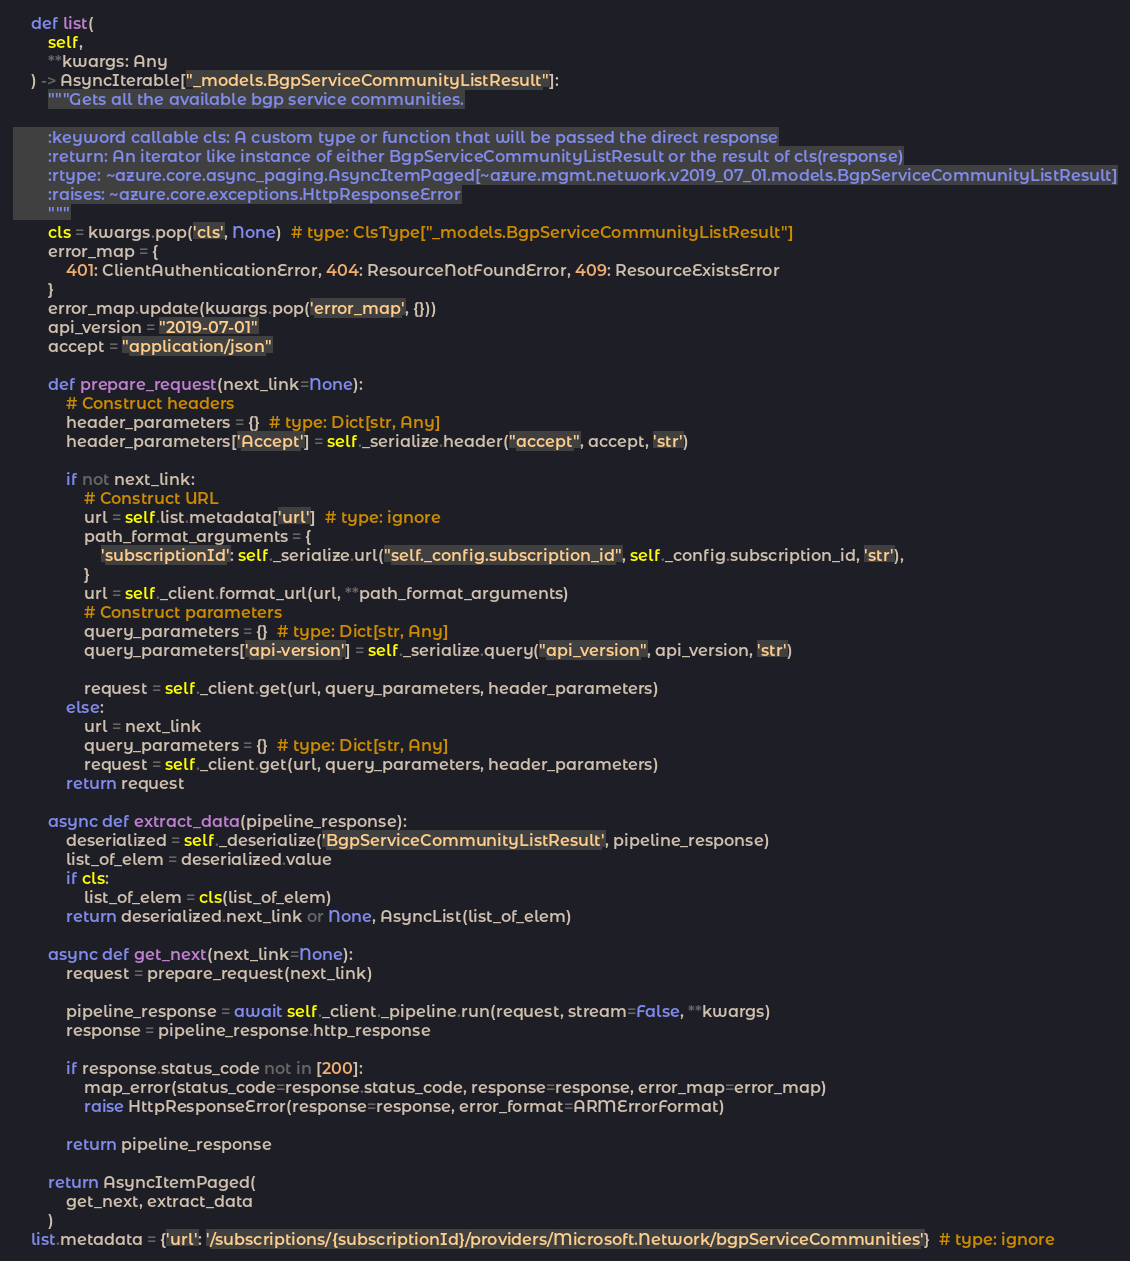<code> <loc_0><loc_0><loc_500><loc_500><_Python_>    def list(
        self,
        **kwargs: Any
    ) -> AsyncIterable["_models.BgpServiceCommunityListResult"]:
        """Gets all the available bgp service communities.

        :keyword callable cls: A custom type or function that will be passed the direct response
        :return: An iterator like instance of either BgpServiceCommunityListResult or the result of cls(response)
        :rtype: ~azure.core.async_paging.AsyncItemPaged[~azure.mgmt.network.v2019_07_01.models.BgpServiceCommunityListResult]
        :raises: ~azure.core.exceptions.HttpResponseError
        """
        cls = kwargs.pop('cls', None)  # type: ClsType["_models.BgpServiceCommunityListResult"]
        error_map = {
            401: ClientAuthenticationError, 404: ResourceNotFoundError, 409: ResourceExistsError
        }
        error_map.update(kwargs.pop('error_map', {}))
        api_version = "2019-07-01"
        accept = "application/json"

        def prepare_request(next_link=None):
            # Construct headers
            header_parameters = {}  # type: Dict[str, Any]
            header_parameters['Accept'] = self._serialize.header("accept", accept, 'str')

            if not next_link:
                # Construct URL
                url = self.list.metadata['url']  # type: ignore
                path_format_arguments = {
                    'subscriptionId': self._serialize.url("self._config.subscription_id", self._config.subscription_id, 'str'),
                }
                url = self._client.format_url(url, **path_format_arguments)
                # Construct parameters
                query_parameters = {}  # type: Dict[str, Any]
                query_parameters['api-version'] = self._serialize.query("api_version", api_version, 'str')

                request = self._client.get(url, query_parameters, header_parameters)
            else:
                url = next_link
                query_parameters = {}  # type: Dict[str, Any]
                request = self._client.get(url, query_parameters, header_parameters)
            return request

        async def extract_data(pipeline_response):
            deserialized = self._deserialize('BgpServiceCommunityListResult', pipeline_response)
            list_of_elem = deserialized.value
            if cls:
                list_of_elem = cls(list_of_elem)
            return deserialized.next_link or None, AsyncList(list_of_elem)

        async def get_next(next_link=None):
            request = prepare_request(next_link)

            pipeline_response = await self._client._pipeline.run(request, stream=False, **kwargs)
            response = pipeline_response.http_response

            if response.status_code not in [200]:
                map_error(status_code=response.status_code, response=response, error_map=error_map)
                raise HttpResponseError(response=response, error_format=ARMErrorFormat)

            return pipeline_response

        return AsyncItemPaged(
            get_next, extract_data
        )
    list.metadata = {'url': '/subscriptions/{subscriptionId}/providers/Microsoft.Network/bgpServiceCommunities'}  # type: ignore
</code> 